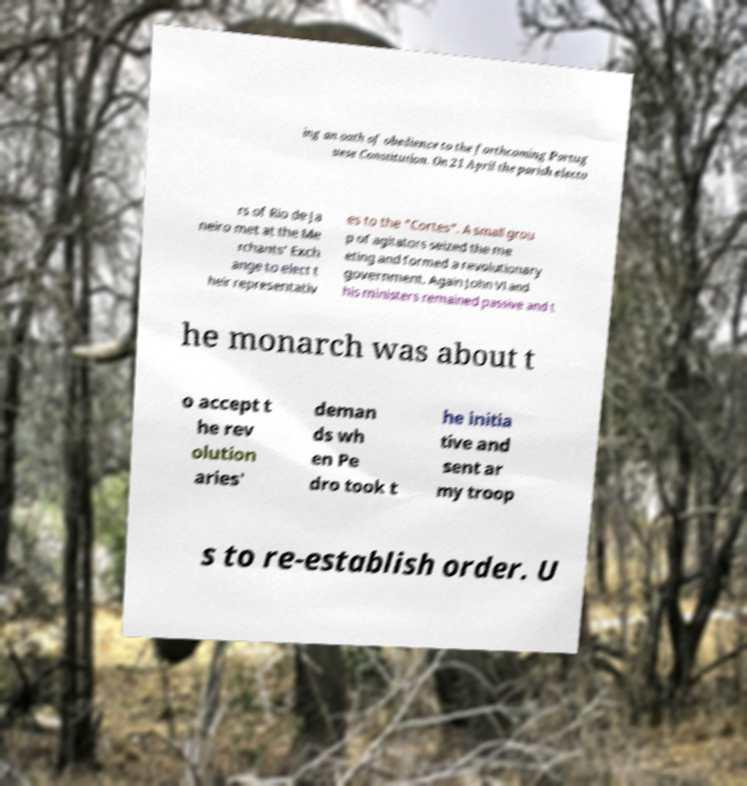Could you extract and type out the text from this image? ing an oath of obedience to the forthcoming Portug uese Constitution. On 21 April the parish electo rs of Rio de Ja neiro met at the Me rchants' Exch ange to elect t heir representativ es to the "Cortes". A small grou p of agitators seized the me eting and formed a revolutionary government. Again John VI and his ministers remained passive and t he monarch was about t o accept t he rev olution aries' deman ds wh en Pe dro took t he initia tive and sent ar my troop s to re-establish order. U 